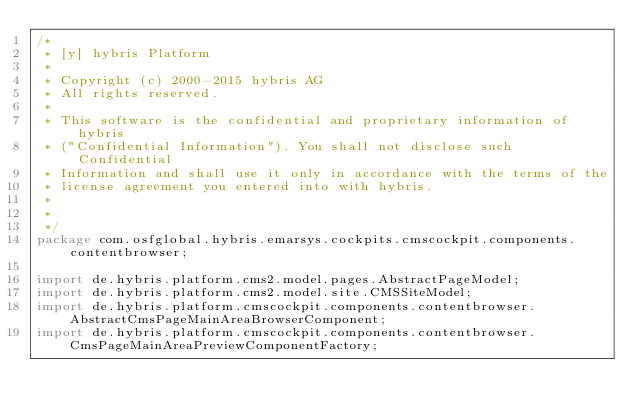Convert code to text. <code><loc_0><loc_0><loc_500><loc_500><_Java_>/*
 * [y] hybris Platform
 *
 * Copyright (c) 2000-2015 hybris AG
 * All rights reserved.
 *
 * This software is the confidential and proprietary information of hybris
 * ("Confidential Information"). You shall not disclose such Confidential
 * Information and shall use it only in accordance with the terms of the
 * license agreement you entered into with hybris.
 *
 *
 */
package com.osfglobal.hybris.emarsys.cockpits.cmscockpit.components.contentbrowser;

import de.hybris.platform.cms2.model.pages.AbstractPageModel;
import de.hybris.platform.cms2.model.site.CMSSiteModel;
import de.hybris.platform.cmscockpit.components.contentbrowser.AbstractCmsPageMainAreaBrowserComponent;
import de.hybris.platform.cmscockpit.components.contentbrowser.CmsPageMainAreaPreviewComponentFactory;</code> 